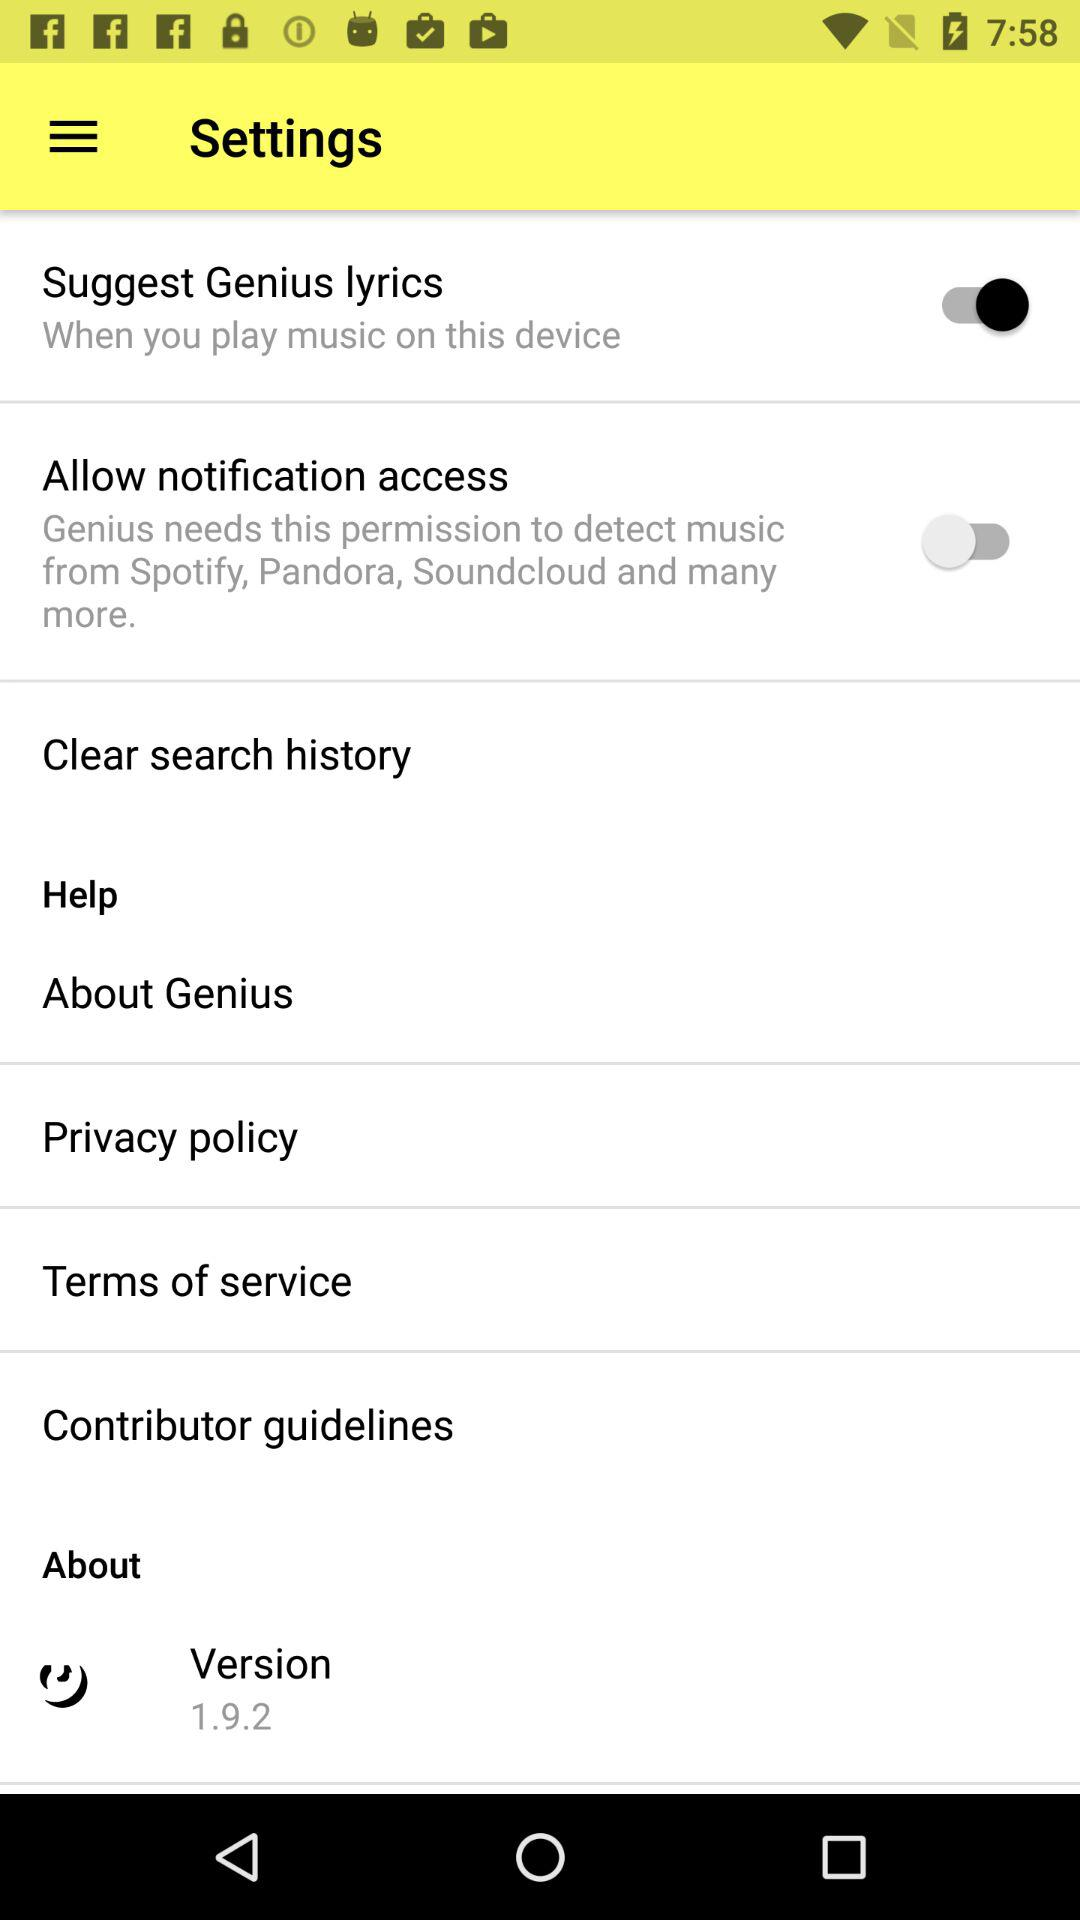What version is this? The version is 1.9.2. 